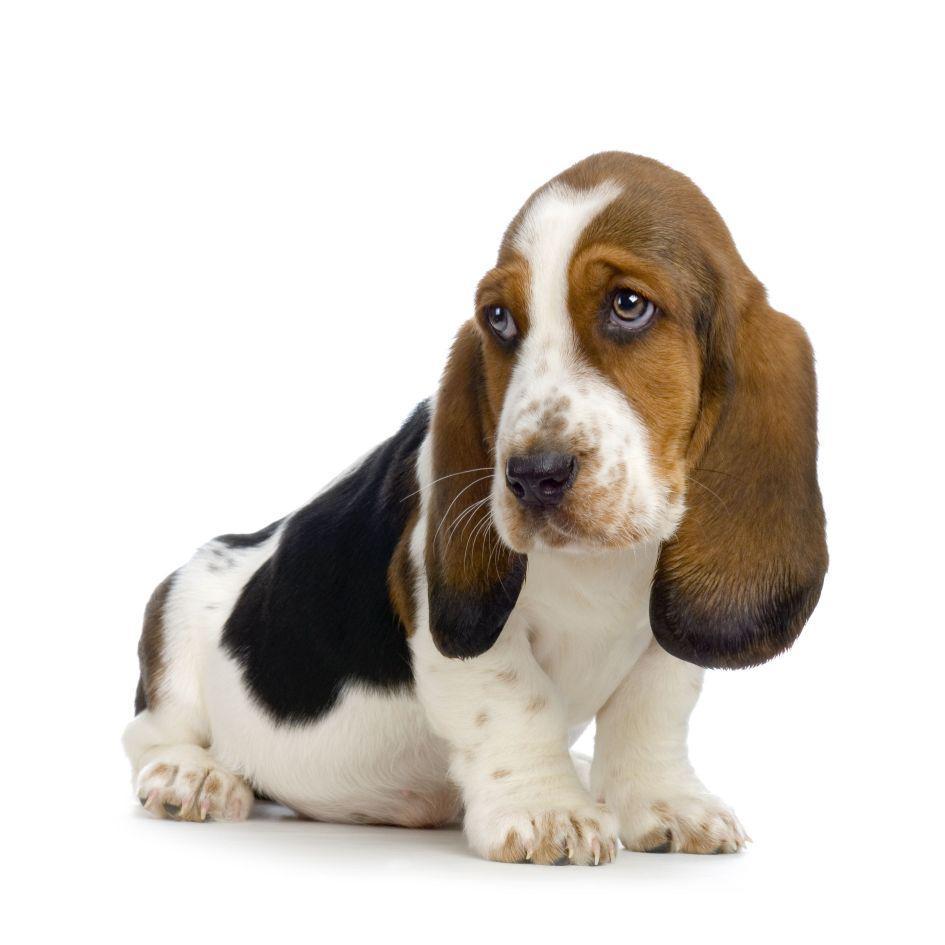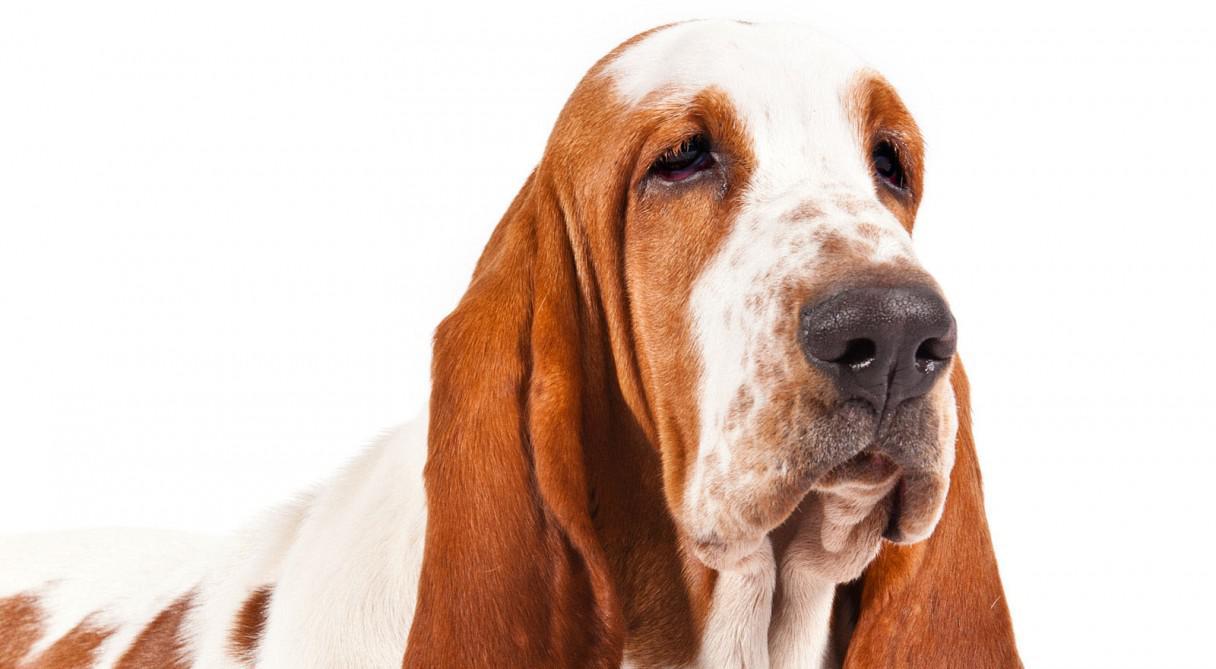The first image is the image on the left, the second image is the image on the right. Examine the images to the left and right. Is the description "The dog in the image on the right is outside." accurate? Answer yes or no. No. 